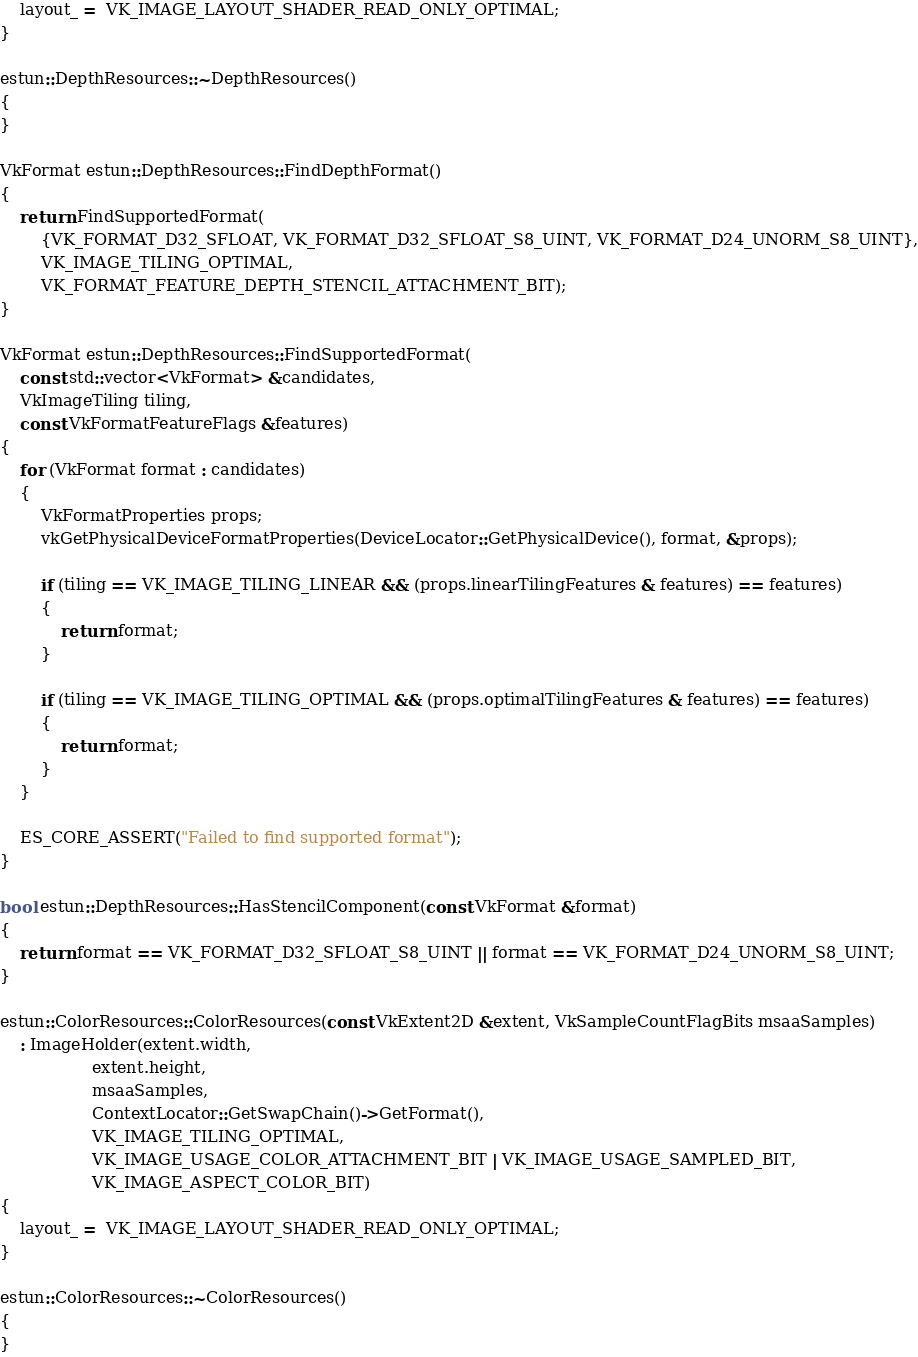<code> <loc_0><loc_0><loc_500><loc_500><_C++_>    layout_ =  VK_IMAGE_LAYOUT_SHADER_READ_ONLY_OPTIMAL;
}

estun::DepthResources::~DepthResources()
{
}

VkFormat estun::DepthResources::FindDepthFormat()
{
    return FindSupportedFormat(
        {VK_FORMAT_D32_SFLOAT, VK_FORMAT_D32_SFLOAT_S8_UINT, VK_FORMAT_D24_UNORM_S8_UINT},
        VK_IMAGE_TILING_OPTIMAL,
        VK_FORMAT_FEATURE_DEPTH_STENCIL_ATTACHMENT_BIT);
}

VkFormat estun::DepthResources::FindSupportedFormat(
    const std::vector<VkFormat> &candidates,
    VkImageTiling tiling,
    const VkFormatFeatureFlags &features)
{
    for (VkFormat format : candidates)
    {
        VkFormatProperties props;
        vkGetPhysicalDeviceFormatProperties(DeviceLocator::GetPhysicalDevice(), format, &props);

        if (tiling == VK_IMAGE_TILING_LINEAR && (props.linearTilingFeatures & features) == features)
        {
            return format;
        }

        if (tiling == VK_IMAGE_TILING_OPTIMAL && (props.optimalTilingFeatures & features) == features)
        {
            return format;
        }
    }

    ES_CORE_ASSERT("Failed to find supported format");
}

bool estun::DepthResources::HasStencilComponent(const VkFormat &format)
{
    return format == VK_FORMAT_D32_SFLOAT_S8_UINT || format == VK_FORMAT_D24_UNORM_S8_UINT;
}

estun::ColorResources::ColorResources(const VkExtent2D &extent, VkSampleCountFlagBits msaaSamples)
    : ImageHolder(extent.width,
                  extent.height,
                  msaaSamples,
                  ContextLocator::GetSwapChain()->GetFormat(),
                  VK_IMAGE_TILING_OPTIMAL,
                  VK_IMAGE_USAGE_COLOR_ATTACHMENT_BIT | VK_IMAGE_USAGE_SAMPLED_BIT,
                  VK_IMAGE_ASPECT_COLOR_BIT)
{
    layout_ =  VK_IMAGE_LAYOUT_SHADER_READ_ONLY_OPTIMAL;
}

estun::ColorResources::~ColorResources()
{
}

</code> 